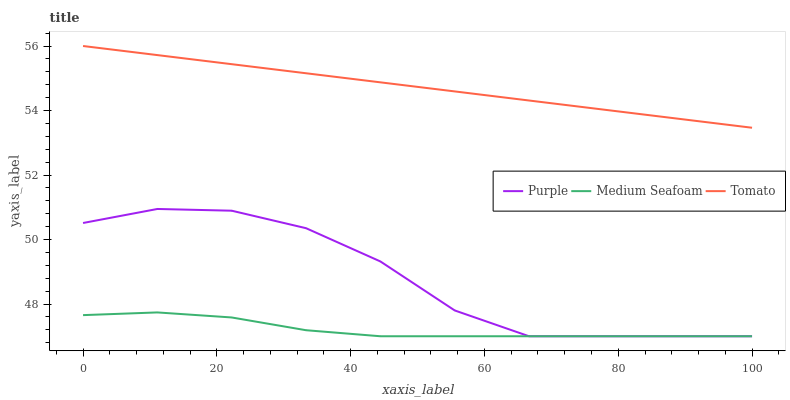Does Medium Seafoam have the minimum area under the curve?
Answer yes or no. Yes. Does Tomato have the maximum area under the curve?
Answer yes or no. Yes. Does Tomato have the minimum area under the curve?
Answer yes or no. No. Does Medium Seafoam have the maximum area under the curve?
Answer yes or no. No. Is Tomato the smoothest?
Answer yes or no. Yes. Is Purple the roughest?
Answer yes or no. Yes. Is Medium Seafoam the smoothest?
Answer yes or no. No. Is Medium Seafoam the roughest?
Answer yes or no. No. Does Purple have the lowest value?
Answer yes or no. Yes. Does Tomato have the lowest value?
Answer yes or no. No. Does Tomato have the highest value?
Answer yes or no. Yes. Does Medium Seafoam have the highest value?
Answer yes or no. No. Is Medium Seafoam less than Tomato?
Answer yes or no. Yes. Is Tomato greater than Medium Seafoam?
Answer yes or no. Yes. Does Purple intersect Medium Seafoam?
Answer yes or no. Yes. Is Purple less than Medium Seafoam?
Answer yes or no. No. Is Purple greater than Medium Seafoam?
Answer yes or no. No. Does Medium Seafoam intersect Tomato?
Answer yes or no. No. 